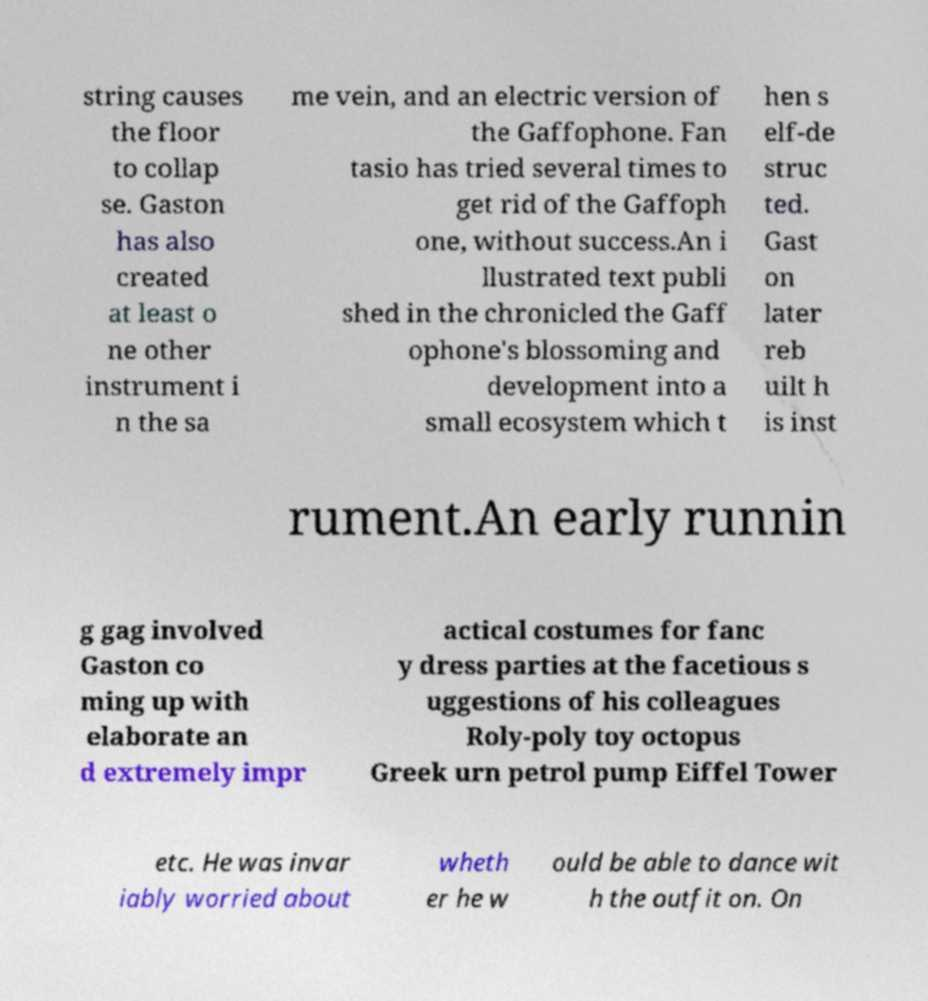Can you read and provide the text displayed in the image?This photo seems to have some interesting text. Can you extract and type it out for me? string causes the floor to collap se. Gaston has also created at least o ne other instrument i n the sa me vein, and an electric version of the Gaffophone. Fan tasio has tried several times to get rid of the Gaffoph one, without success.An i llustrated text publi shed in the chronicled the Gaff ophone's blossoming and development into a small ecosystem which t hen s elf-de struc ted. Gast on later reb uilt h is inst rument.An early runnin g gag involved Gaston co ming up with elaborate an d extremely impr actical costumes for fanc y dress parties at the facetious s uggestions of his colleagues Roly-poly toy octopus Greek urn petrol pump Eiffel Tower etc. He was invar iably worried about wheth er he w ould be able to dance wit h the outfit on. On 